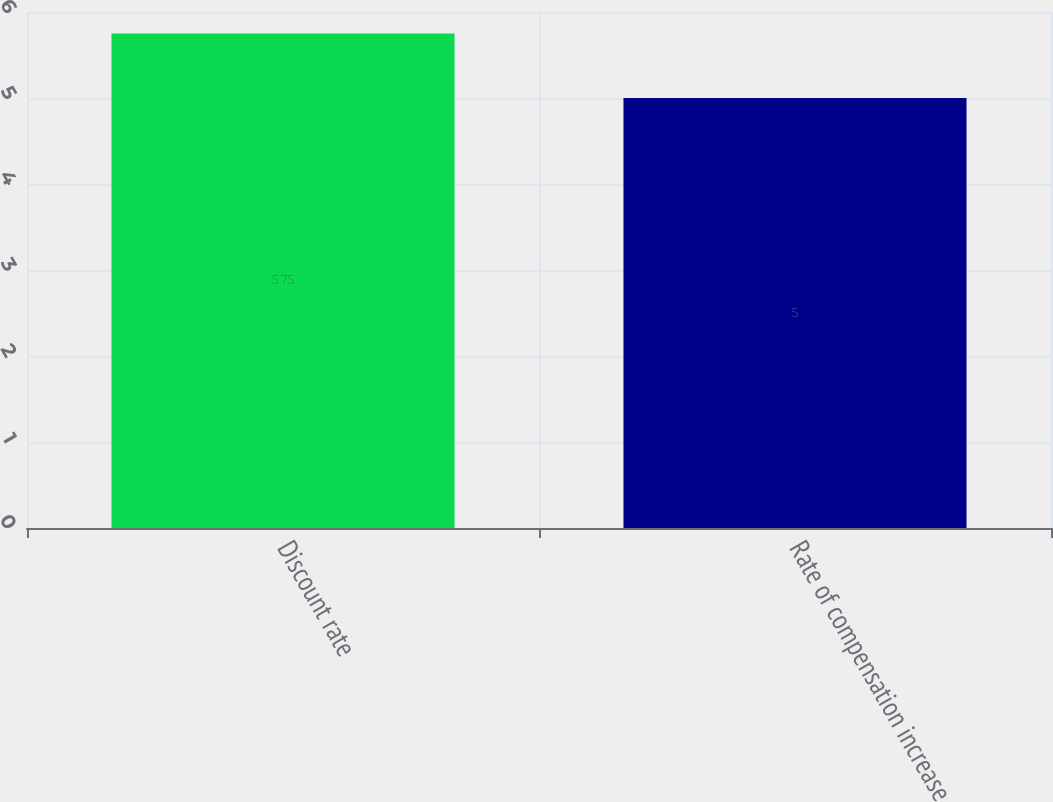<chart> <loc_0><loc_0><loc_500><loc_500><bar_chart><fcel>Discount rate<fcel>Rate of compensation increase<nl><fcel>5.75<fcel>5<nl></chart> 